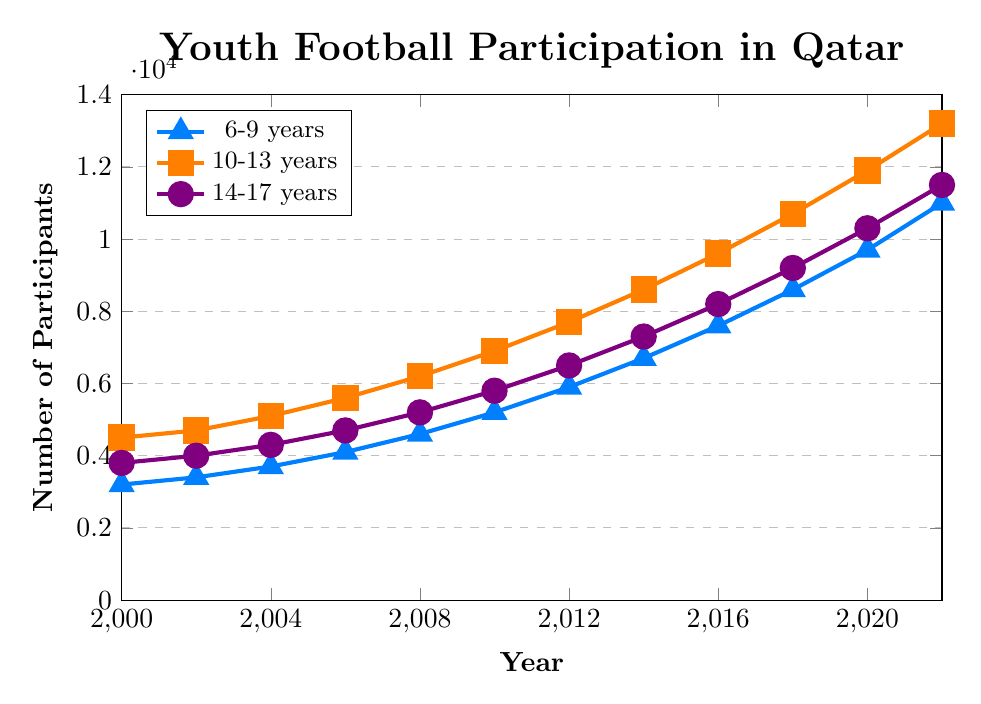What's the number of participants in the 6-9 years age group in 2020? To find the number of participants in the 6-9 years age group in 2020, look at the corresponding point on the line representing the 6-9 years age group for the year 2020.
Answer: 9700 Which age group had the highest participation rate in 2018? Check the values for all age groups in 2018 and compare them to identify the highest one. The 10-13 years age group had 10700 participants, which is the highest.
Answer: 10-13 years By how much did the number of participants increase in the 14-17 years age group from 2000 to 2022? Subtract the number of participants in the 14-17 years age group in 2000 from that in 2022. Specifically, 11500 - 3800 = 7700.
Answer: 7700 What is the difference in participation between the 10-13 years age group and the 6-9 years age group in 2022? Identify the number of participants for both age groups in 2022 and subtract the 6-9 years value from the 10-13 years value: 13200 - 11000 = 2200.
Answer: 2200 Are there any years where the participation rate of the 14-17 years age group exceeds that of the 10-13 years age group? Compare the values for both age groups across all the years; notice that in all instances, the 10-13 years age group has higher or equal numbers.
Answer: No How did the number of participants in the 6-9 years age group change from 2004 to 2006? Find the number of participants in the 6-9 years age group for the years 2004 and 2006 and subtract 2004's value from 2006's value: 4100 - 3700 = 400.
Answer: Increased by 400 Which age group showed the most significant growth rate between 2012 and 2014? Calculate the growth rate for each age group between 2012 and 2014. For the 6-9 years age group: (6700-5900)/5900 = 0.1356, for the 10-13 years: (8600-7700)/7700 = 0.1169, for the 14-17 years age group: (7300-6500)/6500 = 0.1231. The highest growth rate is for the 6-9 years age group.
Answer: 6-9 years What was the average number of participants in the 10-13 years age group over the period shown? Add up all the participants for the 10-13 years age group and divide by the number of data points: (4500 + 4700 + 5100 + 5600 + 6200 + 6900 + 7700 + 8600 + 9600 + 10700 + 11900 + 13200)/12. The average is 8016.67.
Answer: 8016.67 In what year did the 6-9 years age group participation first exceed 5,000? Check the participation data for the 6-9 years age group and find the first year where it exceeds 5,000. This first occurred in 2010 with 5200 participants.
Answer: 2010 